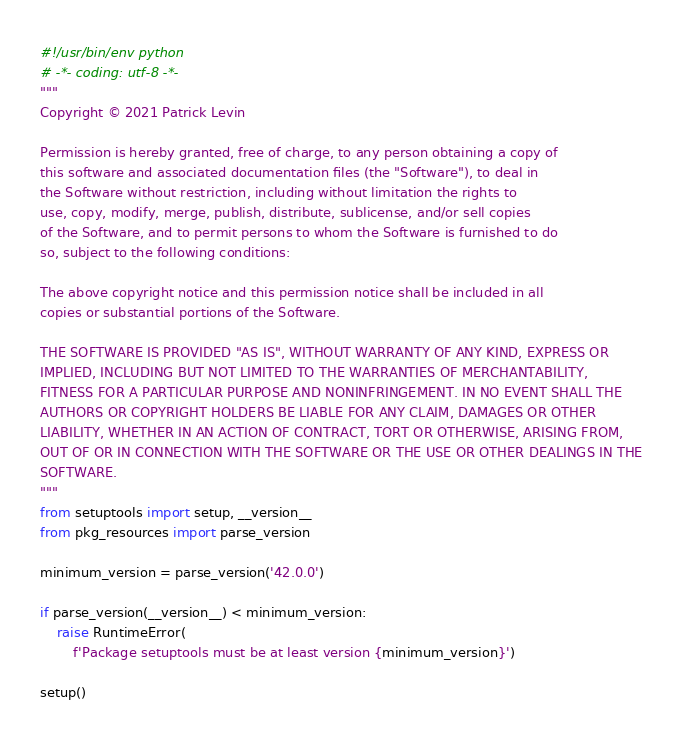<code> <loc_0><loc_0><loc_500><loc_500><_Python_>#!/usr/bin/env python
# -*- coding: utf-8 -*-
"""
Copyright © 2021 Patrick Levin

Permission is hereby granted, free of charge, to any person obtaining a copy of
this software and associated documentation files (the "Software"), to deal in
the Software without restriction, including without limitation the rights to
use, copy, modify, merge, publish, distribute, sublicense, and/or sell copies
of the Software, and to permit persons to whom the Software is furnished to do
so, subject to the following conditions:

The above copyright notice and this permission notice shall be included in all
copies or substantial portions of the Software.

THE SOFTWARE IS PROVIDED "AS IS", WITHOUT WARRANTY OF ANY KIND, EXPRESS OR
IMPLIED, INCLUDING BUT NOT LIMITED TO THE WARRANTIES OF MERCHANTABILITY,
FITNESS FOR A PARTICULAR PURPOSE AND NONINFRINGEMENT. IN NO EVENT SHALL THE
AUTHORS OR COPYRIGHT HOLDERS BE LIABLE FOR ANY CLAIM, DAMAGES OR OTHER
LIABILITY, WHETHER IN AN ACTION OF CONTRACT, TORT OR OTHERWISE, ARISING FROM,
OUT OF OR IN CONNECTION WITH THE SOFTWARE OR THE USE OR OTHER DEALINGS IN THE
SOFTWARE.
"""
from setuptools import setup, __version__
from pkg_resources import parse_version

minimum_version = parse_version('42.0.0')

if parse_version(__version__) < minimum_version:
    raise RuntimeError(
        f'Package setuptools must be at least version {minimum_version}')

setup()
</code> 